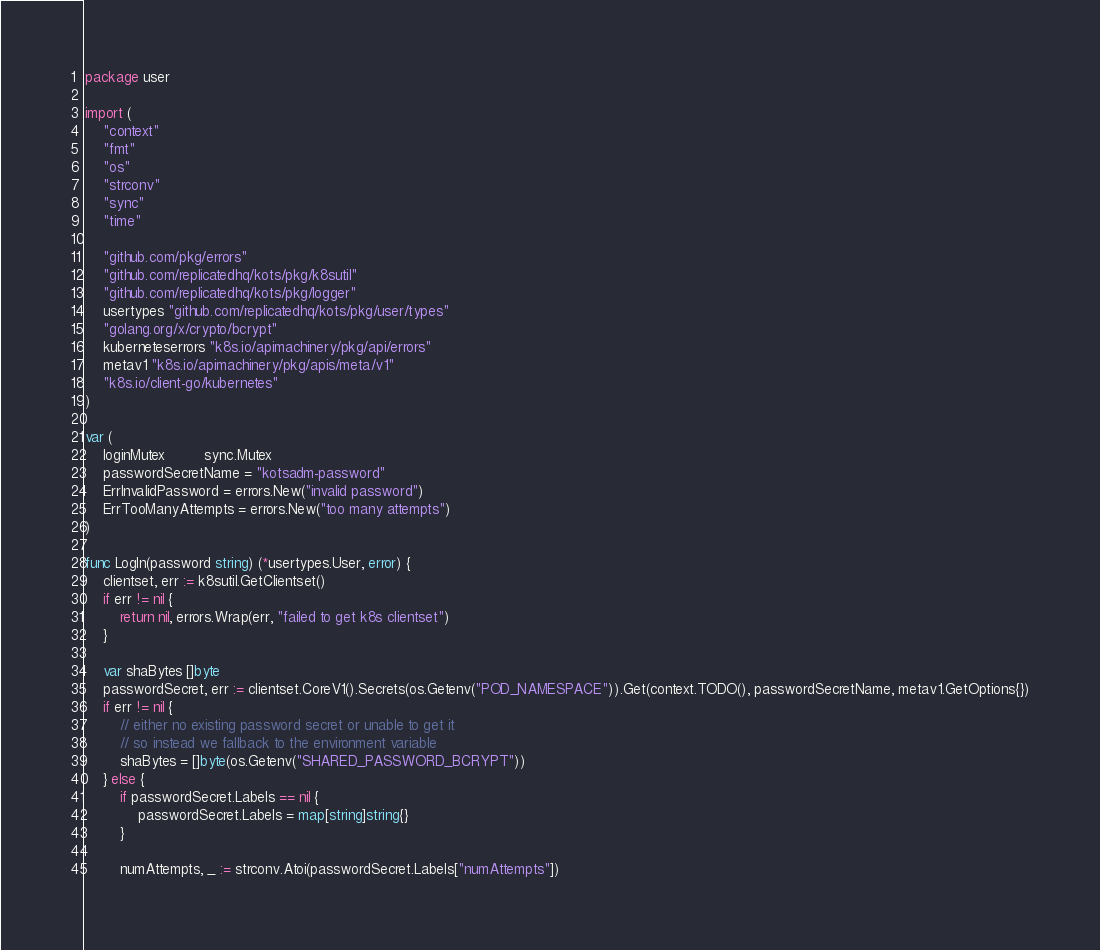<code> <loc_0><loc_0><loc_500><loc_500><_Go_>package user

import (
	"context"
	"fmt"
	"os"
	"strconv"
	"sync"
	"time"

	"github.com/pkg/errors"
	"github.com/replicatedhq/kots/pkg/k8sutil"
	"github.com/replicatedhq/kots/pkg/logger"
	usertypes "github.com/replicatedhq/kots/pkg/user/types"
	"golang.org/x/crypto/bcrypt"
	kuberneteserrors "k8s.io/apimachinery/pkg/api/errors"
	metav1 "k8s.io/apimachinery/pkg/apis/meta/v1"
	"k8s.io/client-go/kubernetes"
)

var (
	loginMutex         sync.Mutex
	passwordSecretName = "kotsadm-password"
	ErrInvalidPassword = errors.New("invalid password")
	ErrTooManyAttempts = errors.New("too many attempts")
)

func LogIn(password string) (*usertypes.User, error) {
	clientset, err := k8sutil.GetClientset()
	if err != nil {
		return nil, errors.Wrap(err, "failed to get k8s clientset")
	}

	var shaBytes []byte
	passwordSecret, err := clientset.CoreV1().Secrets(os.Getenv("POD_NAMESPACE")).Get(context.TODO(), passwordSecretName, metav1.GetOptions{})
	if err != nil {
		// either no existing password secret or unable to get it
		// so instead we fallback to the environment variable
		shaBytes = []byte(os.Getenv("SHARED_PASSWORD_BCRYPT"))
	} else {
		if passwordSecret.Labels == nil {
			passwordSecret.Labels = map[string]string{}
		}

		numAttempts, _ := strconv.Atoi(passwordSecret.Labels["numAttempts"])</code> 